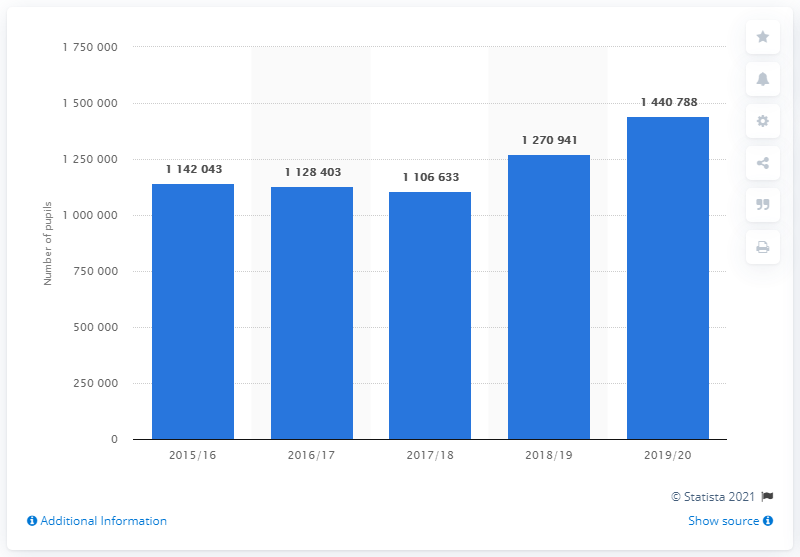Identify some key points in this picture. In the 2018/19 academic year, a total of 1,270,941 pupils were eligible for free school meals. 